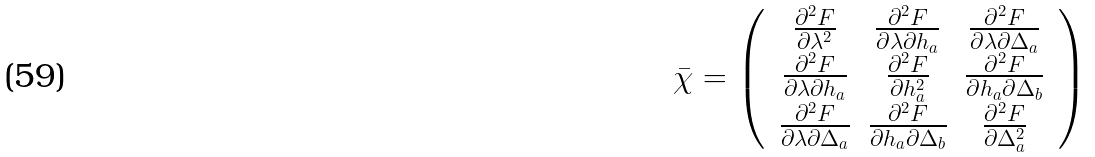<formula> <loc_0><loc_0><loc_500><loc_500>\bar { \chi } = \left ( \, \begin{array} { c c c } \frac { \partial ^ { 2 } F } { \partial \lambda ^ { 2 } } & \frac { \partial ^ { 2 } F } { \partial \lambda \partial h _ { a } } & \frac { \partial ^ { 2 } F } { \partial \lambda \partial \Delta _ { a } } \\ \frac { \partial ^ { 2 } F } { \partial \lambda \partial h _ { a } } & \frac { \partial ^ { 2 } F } { \partial h _ { a } ^ { 2 } } & \frac { \partial ^ { 2 } F } { \partial h _ { a } \partial \Delta _ { b } } \\ \frac { \partial ^ { 2 } F } { \partial \lambda \partial \Delta _ { a } } & \frac { \partial ^ { 2 } F } { \partial h _ { a } \partial \Delta _ { b } } & \frac { \partial ^ { 2 } F } { \partial \Delta _ { a } ^ { 2 } } \\ \end{array} \, \right )</formula> 